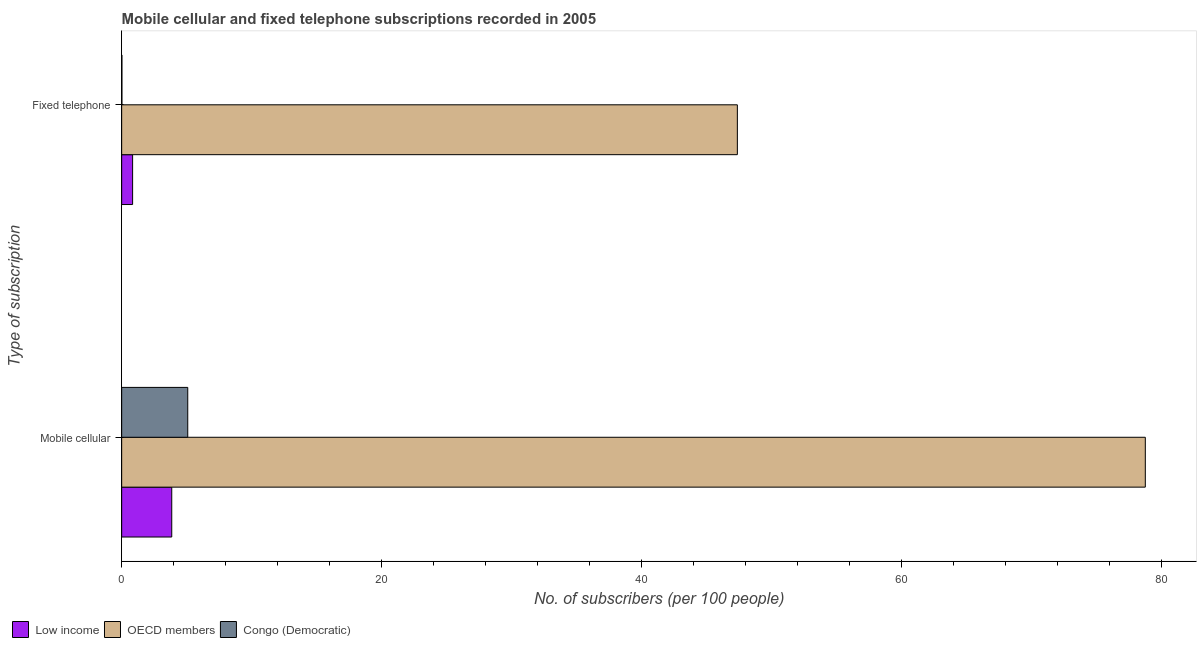Are the number of bars on each tick of the Y-axis equal?
Keep it short and to the point. Yes. What is the label of the 1st group of bars from the top?
Your response must be concise. Fixed telephone. What is the number of fixed telephone subscribers in OECD members?
Make the answer very short. 47.36. Across all countries, what is the maximum number of fixed telephone subscribers?
Offer a very short reply. 47.36. Across all countries, what is the minimum number of fixed telephone subscribers?
Offer a very short reply. 0.02. What is the total number of fixed telephone subscribers in the graph?
Provide a short and direct response. 48.22. What is the difference between the number of mobile cellular subscribers in Congo (Democratic) and that in OECD members?
Ensure brevity in your answer.  -73.66. What is the difference between the number of fixed telephone subscribers in OECD members and the number of mobile cellular subscribers in Low income?
Make the answer very short. 43.51. What is the average number of mobile cellular subscribers per country?
Your response must be concise. 29.23. What is the difference between the number of mobile cellular subscribers and number of fixed telephone subscribers in Congo (Democratic)?
Keep it short and to the point. 5.06. In how many countries, is the number of mobile cellular subscribers greater than 64 ?
Provide a succinct answer. 1. What is the ratio of the number of mobile cellular subscribers in OECD members to that in Congo (Democratic)?
Ensure brevity in your answer.  15.49. In how many countries, is the number of mobile cellular subscribers greater than the average number of mobile cellular subscribers taken over all countries?
Your response must be concise. 1. What does the 1st bar from the top in Mobile cellular represents?
Ensure brevity in your answer.  Congo (Democratic). What does the 1st bar from the bottom in Mobile cellular represents?
Provide a short and direct response. Low income. How many bars are there?
Offer a very short reply. 6. What is the difference between two consecutive major ticks on the X-axis?
Provide a succinct answer. 20. Where does the legend appear in the graph?
Your response must be concise. Bottom left. How many legend labels are there?
Keep it short and to the point. 3. How are the legend labels stacked?
Your response must be concise. Horizontal. What is the title of the graph?
Give a very brief answer. Mobile cellular and fixed telephone subscriptions recorded in 2005. Does "Egypt, Arab Rep." appear as one of the legend labels in the graph?
Offer a very short reply. No. What is the label or title of the X-axis?
Make the answer very short. No. of subscribers (per 100 people). What is the label or title of the Y-axis?
Make the answer very short. Type of subscription. What is the No. of subscribers (per 100 people) of Low income in Mobile cellular?
Make the answer very short. 3.85. What is the No. of subscribers (per 100 people) in OECD members in Mobile cellular?
Offer a terse response. 78.75. What is the No. of subscribers (per 100 people) of Congo (Democratic) in Mobile cellular?
Offer a terse response. 5.08. What is the No. of subscribers (per 100 people) in Low income in Fixed telephone?
Give a very brief answer. 0.84. What is the No. of subscribers (per 100 people) of OECD members in Fixed telephone?
Your answer should be very brief. 47.36. What is the No. of subscribers (per 100 people) in Congo (Democratic) in Fixed telephone?
Provide a succinct answer. 0.02. Across all Type of subscription, what is the maximum No. of subscribers (per 100 people) in Low income?
Your answer should be very brief. 3.85. Across all Type of subscription, what is the maximum No. of subscribers (per 100 people) in OECD members?
Offer a very short reply. 78.75. Across all Type of subscription, what is the maximum No. of subscribers (per 100 people) of Congo (Democratic)?
Keep it short and to the point. 5.08. Across all Type of subscription, what is the minimum No. of subscribers (per 100 people) in Low income?
Provide a succinct answer. 0.84. Across all Type of subscription, what is the minimum No. of subscribers (per 100 people) of OECD members?
Provide a succinct answer. 47.36. Across all Type of subscription, what is the minimum No. of subscribers (per 100 people) of Congo (Democratic)?
Offer a terse response. 0.02. What is the total No. of subscribers (per 100 people) in Low income in the graph?
Keep it short and to the point. 4.69. What is the total No. of subscribers (per 100 people) in OECD members in the graph?
Your answer should be compact. 126.11. What is the total No. of subscribers (per 100 people) of Congo (Democratic) in the graph?
Offer a very short reply. 5.1. What is the difference between the No. of subscribers (per 100 people) in Low income in Mobile cellular and that in Fixed telephone?
Provide a succinct answer. 3.01. What is the difference between the No. of subscribers (per 100 people) of OECD members in Mobile cellular and that in Fixed telephone?
Offer a very short reply. 31.38. What is the difference between the No. of subscribers (per 100 people) in Congo (Democratic) in Mobile cellular and that in Fixed telephone?
Make the answer very short. 5.06. What is the difference between the No. of subscribers (per 100 people) in Low income in Mobile cellular and the No. of subscribers (per 100 people) in OECD members in Fixed telephone?
Your answer should be compact. -43.51. What is the difference between the No. of subscribers (per 100 people) of Low income in Mobile cellular and the No. of subscribers (per 100 people) of Congo (Democratic) in Fixed telephone?
Offer a terse response. 3.83. What is the difference between the No. of subscribers (per 100 people) in OECD members in Mobile cellular and the No. of subscribers (per 100 people) in Congo (Democratic) in Fixed telephone?
Your answer should be compact. 78.73. What is the average No. of subscribers (per 100 people) of Low income per Type of subscription?
Provide a succinct answer. 2.35. What is the average No. of subscribers (per 100 people) of OECD members per Type of subscription?
Keep it short and to the point. 63.06. What is the average No. of subscribers (per 100 people) of Congo (Democratic) per Type of subscription?
Your answer should be very brief. 2.55. What is the difference between the No. of subscribers (per 100 people) of Low income and No. of subscribers (per 100 people) of OECD members in Mobile cellular?
Offer a very short reply. -74.89. What is the difference between the No. of subscribers (per 100 people) of Low income and No. of subscribers (per 100 people) of Congo (Democratic) in Mobile cellular?
Give a very brief answer. -1.23. What is the difference between the No. of subscribers (per 100 people) in OECD members and No. of subscribers (per 100 people) in Congo (Democratic) in Mobile cellular?
Give a very brief answer. 73.66. What is the difference between the No. of subscribers (per 100 people) in Low income and No. of subscribers (per 100 people) in OECD members in Fixed telephone?
Your response must be concise. -46.52. What is the difference between the No. of subscribers (per 100 people) of Low income and No. of subscribers (per 100 people) of Congo (Democratic) in Fixed telephone?
Your answer should be very brief. 0.82. What is the difference between the No. of subscribers (per 100 people) in OECD members and No. of subscribers (per 100 people) in Congo (Democratic) in Fixed telephone?
Give a very brief answer. 47.34. What is the ratio of the No. of subscribers (per 100 people) of Low income in Mobile cellular to that in Fixed telephone?
Ensure brevity in your answer.  4.58. What is the ratio of the No. of subscribers (per 100 people) of OECD members in Mobile cellular to that in Fixed telephone?
Your answer should be very brief. 1.66. What is the ratio of the No. of subscribers (per 100 people) of Congo (Democratic) in Mobile cellular to that in Fixed telephone?
Your response must be concise. 259.58. What is the difference between the highest and the second highest No. of subscribers (per 100 people) of Low income?
Give a very brief answer. 3.01. What is the difference between the highest and the second highest No. of subscribers (per 100 people) in OECD members?
Give a very brief answer. 31.38. What is the difference between the highest and the second highest No. of subscribers (per 100 people) in Congo (Democratic)?
Ensure brevity in your answer.  5.06. What is the difference between the highest and the lowest No. of subscribers (per 100 people) of Low income?
Keep it short and to the point. 3.01. What is the difference between the highest and the lowest No. of subscribers (per 100 people) in OECD members?
Make the answer very short. 31.38. What is the difference between the highest and the lowest No. of subscribers (per 100 people) of Congo (Democratic)?
Keep it short and to the point. 5.06. 